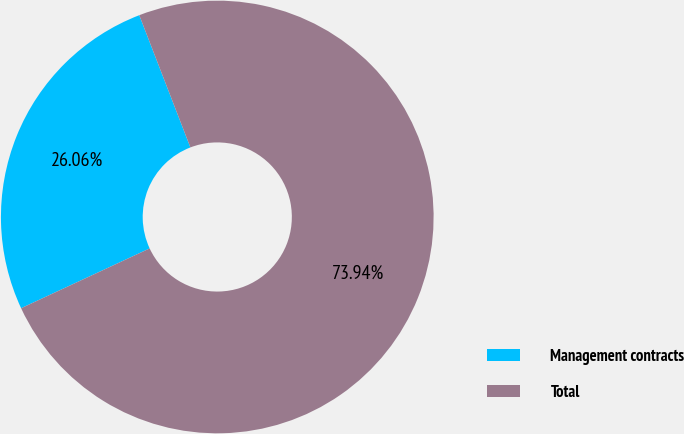Convert chart. <chart><loc_0><loc_0><loc_500><loc_500><pie_chart><fcel>Management contracts<fcel>Total<nl><fcel>26.06%<fcel>73.94%<nl></chart> 